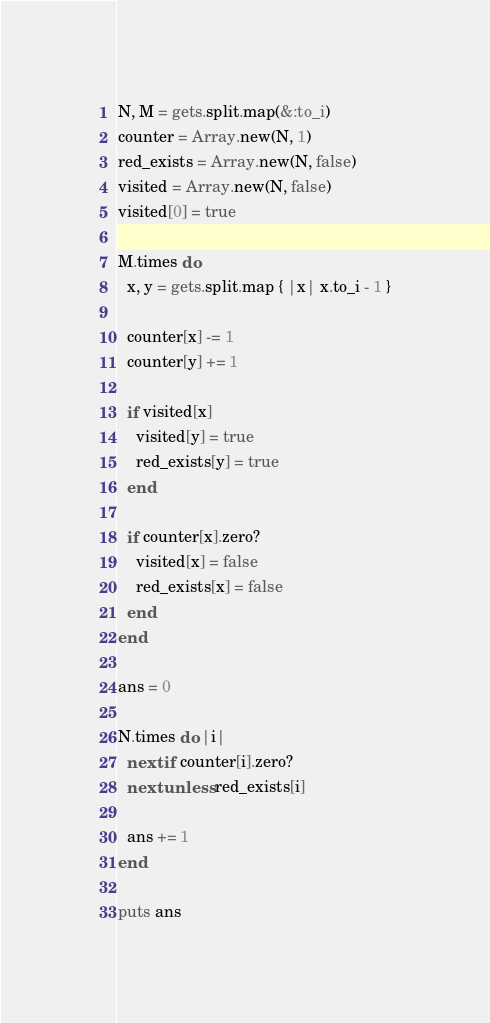Convert code to text. <code><loc_0><loc_0><loc_500><loc_500><_Ruby_>N, M = gets.split.map(&:to_i)
counter = Array.new(N, 1)
red_exists = Array.new(N, false)
visited = Array.new(N, false)
visited[0] = true

M.times do
  x, y = gets.split.map { |x| x.to_i - 1 }

  counter[x] -= 1
  counter[y] += 1

  if visited[x]
    visited[y] = true
    red_exists[y] = true
  end

  if counter[x].zero?
    visited[x] = false
    red_exists[x] = false
  end
end

ans = 0

N.times do |i|
  next if counter[i].zero?
  next unless red_exists[i]

  ans += 1
end

puts ans

</code> 